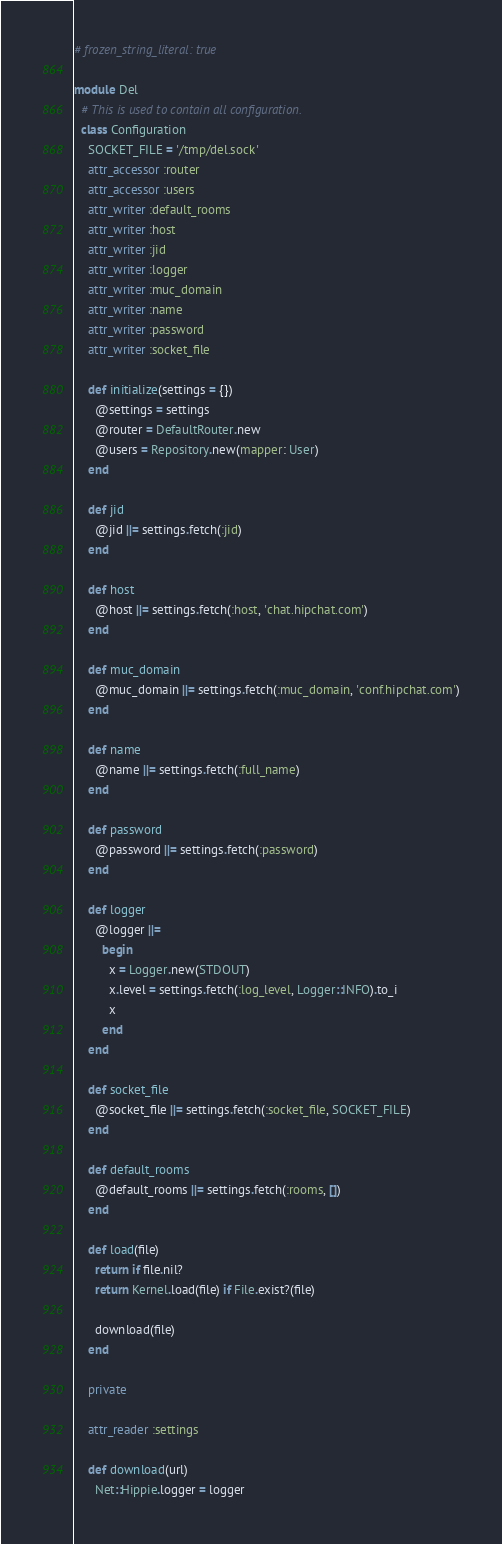<code> <loc_0><loc_0><loc_500><loc_500><_Ruby_># frozen_string_literal: true

module Del
  # This is used to contain all configuration.
  class Configuration
    SOCKET_FILE = '/tmp/del.sock'
    attr_accessor :router
    attr_accessor :users
    attr_writer :default_rooms
    attr_writer :host
    attr_writer :jid
    attr_writer :logger
    attr_writer :muc_domain
    attr_writer :name
    attr_writer :password
    attr_writer :socket_file

    def initialize(settings = {})
      @settings = settings
      @router = DefaultRouter.new
      @users = Repository.new(mapper: User)
    end

    def jid
      @jid ||= settings.fetch(:jid)
    end

    def host
      @host ||= settings.fetch(:host, 'chat.hipchat.com')
    end

    def muc_domain
      @muc_domain ||= settings.fetch(:muc_domain, 'conf.hipchat.com')
    end

    def name
      @name ||= settings.fetch(:full_name)
    end

    def password
      @password ||= settings.fetch(:password)
    end

    def logger
      @logger ||=
        begin
          x = Logger.new(STDOUT)
          x.level = settings.fetch(:log_level, Logger::INFO).to_i
          x
        end
    end

    def socket_file
      @socket_file ||= settings.fetch(:socket_file, SOCKET_FILE)
    end

    def default_rooms
      @default_rooms ||= settings.fetch(:rooms, [])
    end

    def load(file)
      return if file.nil?
      return Kernel.load(file) if File.exist?(file)

      download(file)
    end

    private

    attr_reader :settings

    def download(url)
      Net::Hippie.logger = logger
</code> 